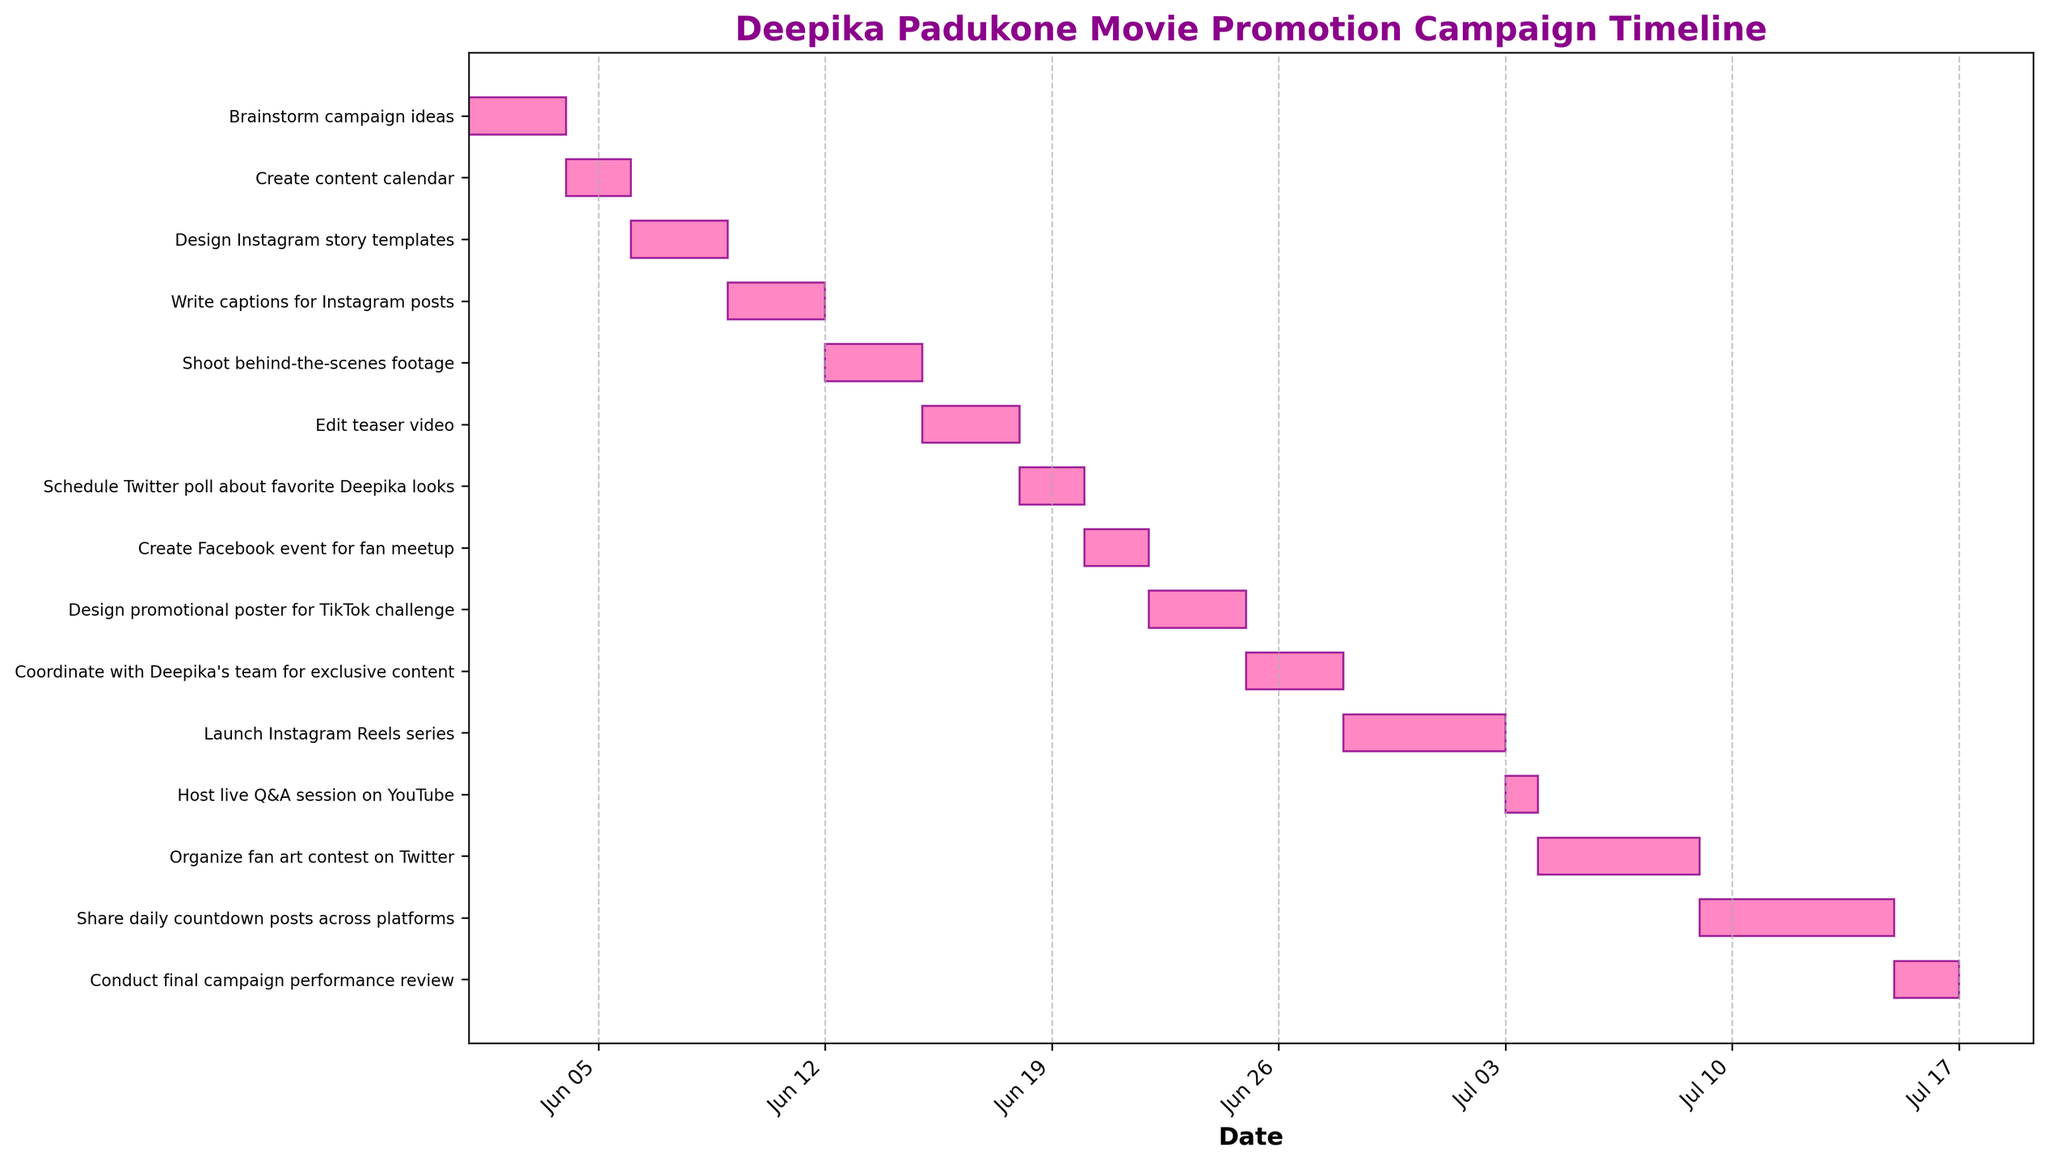What is the title of the Gantt chart? The title of the Gantt chart is mentioned at the top of the figure. It describes the overall theme or purpose of the timeline presented.
Answer: Deepika Padukone Movie Promotion Campaign Timeline What color are the bars in the Gantt chart? The color of the bars in the Gantt chart can be observed directly from the figure. Each bar representing a task has a consistent color.
Answer: Pink When does the task 'Write captions for Instagram posts' start and end? Locate the 'Write captions for Instagram posts' task on the y-axis and check its corresponding start and end dates on the x-axis.
Answer: 2023-06-09 to 2023-06-11 Which task is scheduled to finish on July 3rd? Look for the task bar that coincides with the date July 3rd on the x-axis. This can be found by matching the timeline with the task names.
Answer: Host live Q&A session on YouTube How many tasks are scheduled to end in June? Count all the tasks where the end date falls within the month of June.
Answer: 10 What is the duration of the task 'Organize fan art contest on Twitter'? Find the 'Organize fan art contest on Twitter' task and subtract its start date from its end date, then add 1 to include both start and end dates.
Answer: 5 days Which task has the longest duration, and how long is it? Compare the durations of all the tasks by observing the length of the bars and determine which one is the longest.
Answer: Launch Instagram Reels series, 5 days Are there any tasks that overlap in their start and end dates? Check for tasks that share any common dates on the x-axis by looking at where the bars overlap each other.
Answer: Yes What tasks are scheduled to take place entirely in the first week of June? Identify the bars that fall between June 1st and June 7th without extending beyond those dates.
Answer: Brainstorm campaign ideas, Create content calendar When does the task 'Share daily countdown posts across platforms' start and when does it end? Locate the 'Share daily countdown posts across platforms' task on the y-axis and check its corresponding start and end dates on the x-axis.
Answer: 2023-07-09 to 2023-07-14 